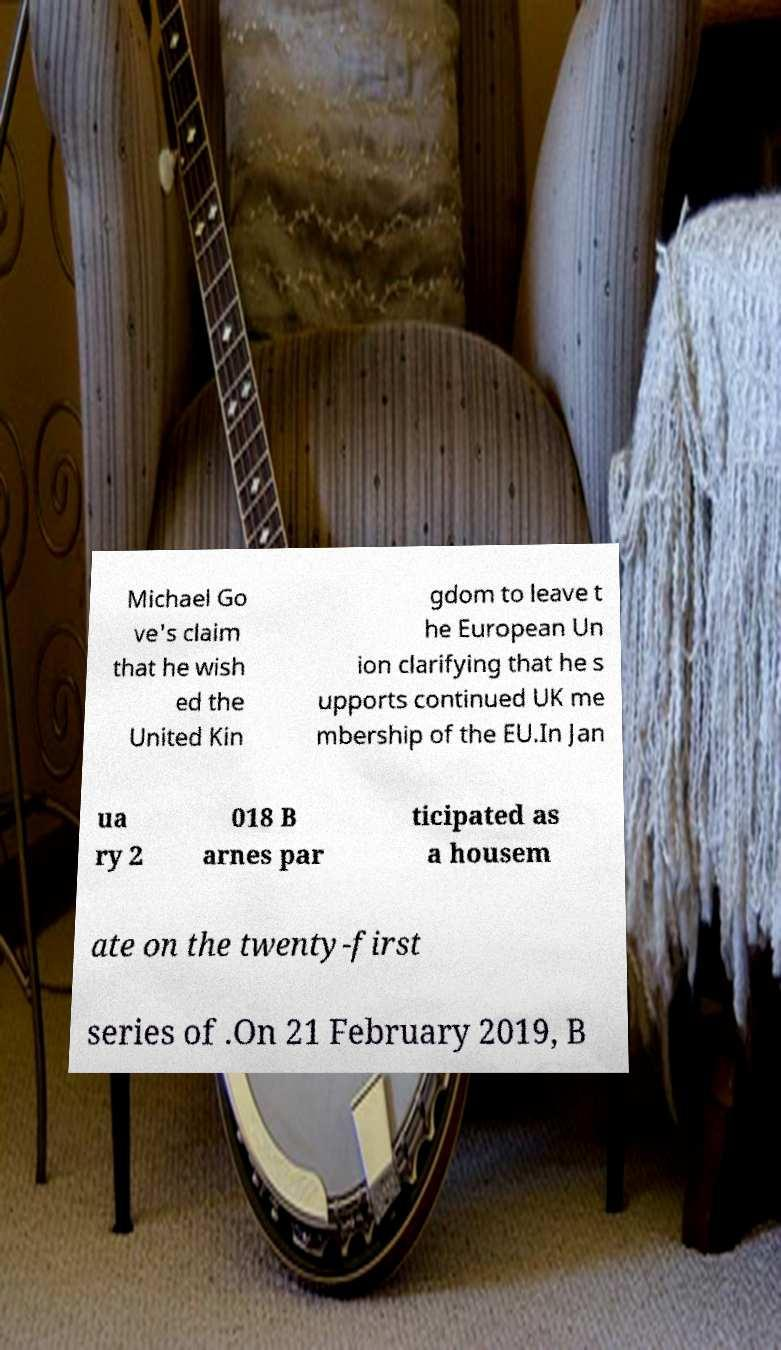Could you extract and type out the text from this image? Michael Go ve's claim that he wish ed the United Kin gdom to leave t he European Un ion clarifying that he s upports continued UK me mbership of the EU.In Jan ua ry 2 018 B arnes par ticipated as a housem ate on the twenty-first series of .On 21 February 2019, B 